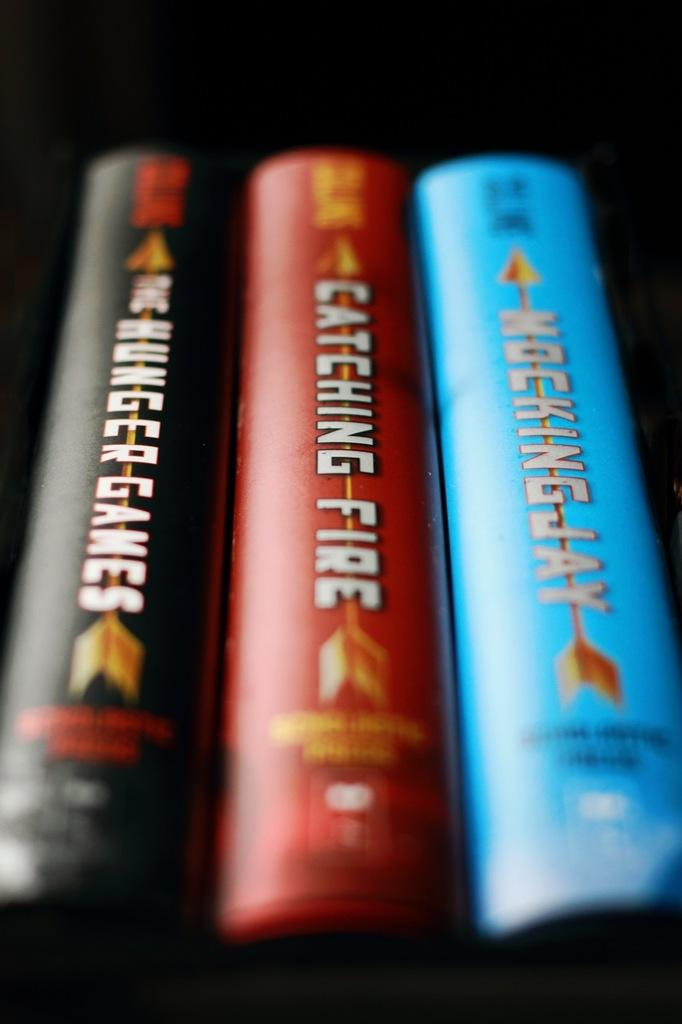<image>
Share a concise interpretation of the image provided. Books from the hunger games series are in a row. 